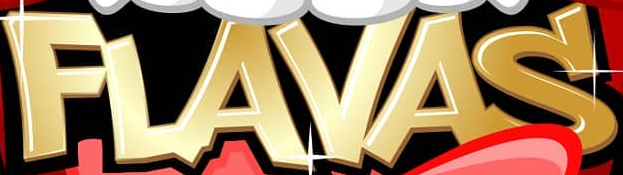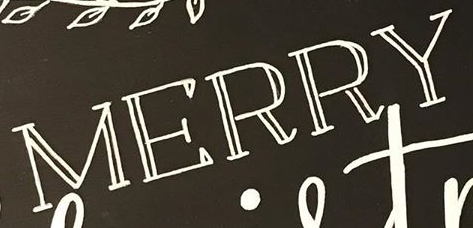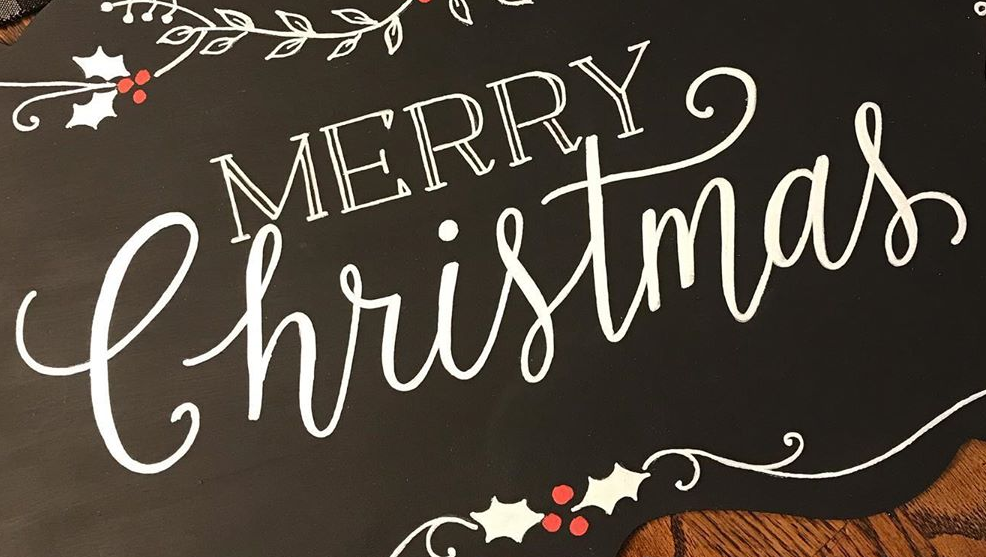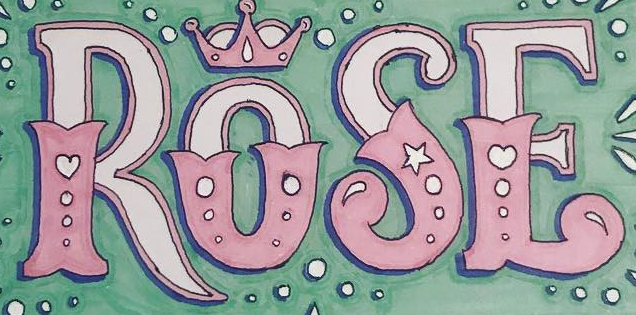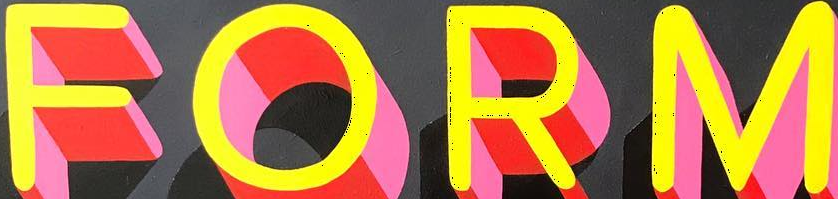What text appears in these images from left to right, separated by a semicolon? FLAVAS; MERRY; Christmas; ROSE; FORM 